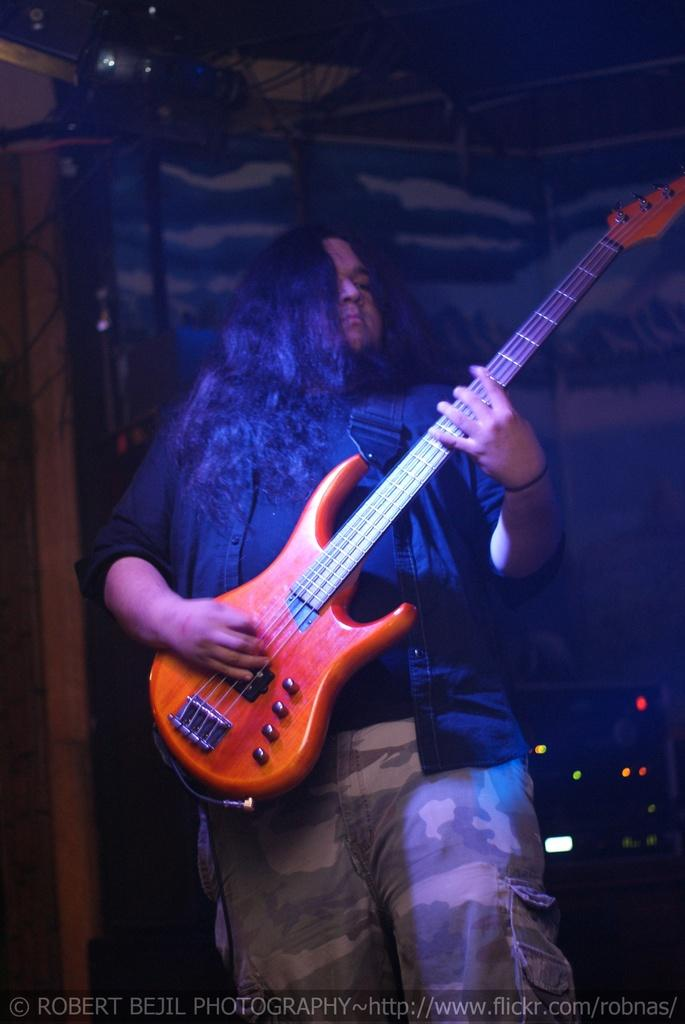What is the main subject of the image? There is a man in the image. What is the man holding in the image? The man is holding a guitar. What type of grain can be seen in the alley behind the man in the image? There is no alley or grain present in the image; it only features a man holding a guitar. 